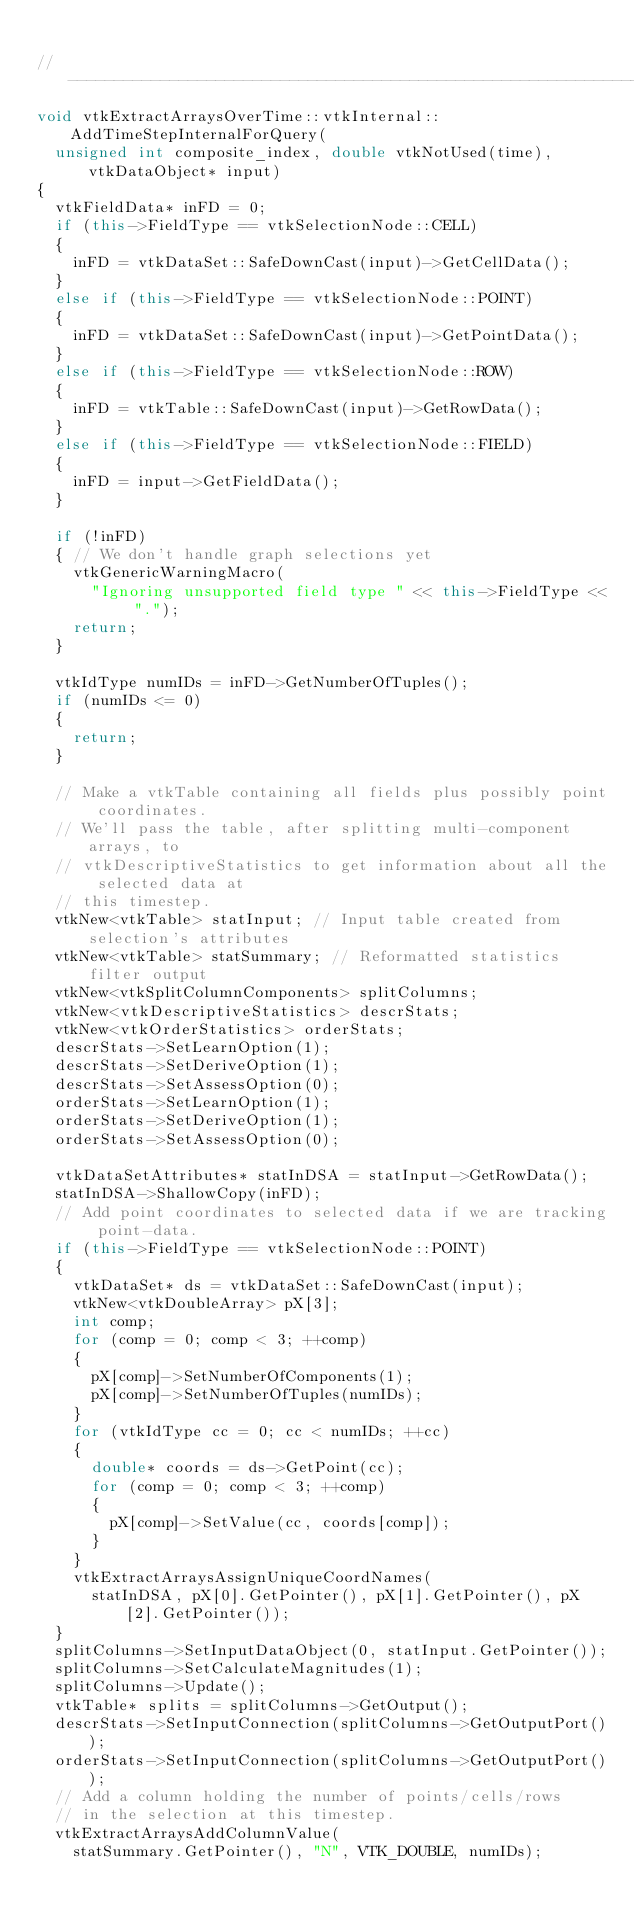<code> <loc_0><loc_0><loc_500><loc_500><_C++_>
//------------------------------------------------------------------------------
void vtkExtractArraysOverTime::vtkInternal::AddTimeStepInternalForQuery(
  unsigned int composite_index, double vtkNotUsed(time), vtkDataObject* input)
{
  vtkFieldData* inFD = 0;
  if (this->FieldType == vtkSelectionNode::CELL)
  {
    inFD = vtkDataSet::SafeDownCast(input)->GetCellData();
  }
  else if (this->FieldType == vtkSelectionNode::POINT)
  {
    inFD = vtkDataSet::SafeDownCast(input)->GetPointData();
  }
  else if (this->FieldType == vtkSelectionNode::ROW)
  {
    inFD = vtkTable::SafeDownCast(input)->GetRowData();
  }
  else if (this->FieldType == vtkSelectionNode::FIELD)
  {
    inFD = input->GetFieldData();
  }

  if (!inFD)
  { // We don't handle graph selections yet
    vtkGenericWarningMacro(
      "Ignoring unsupported field type " << this->FieldType << ".");
    return;
  }

  vtkIdType numIDs = inFD->GetNumberOfTuples();
  if (numIDs <= 0)
  {
    return;
  }

  // Make a vtkTable containing all fields plus possibly point coordinates.
  // We'll pass the table, after splitting multi-component arrays, to
  // vtkDescriptiveStatistics to get information about all the selected data at
  // this timestep.
  vtkNew<vtkTable> statInput; // Input table created from selection's attributes
  vtkNew<vtkTable> statSummary; // Reformatted statistics filter output
  vtkNew<vtkSplitColumnComponents> splitColumns;
  vtkNew<vtkDescriptiveStatistics> descrStats;
  vtkNew<vtkOrderStatistics> orderStats;
  descrStats->SetLearnOption(1);
  descrStats->SetDeriveOption(1);
  descrStats->SetAssessOption(0);
  orderStats->SetLearnOption(1);
  orderStats->SetDeriveOption(1);
  orderStats->SetAssessOption(0);

  vtkDataSetAttributes* statInDSA = statInput->GetRowData();
  statInDSA->ShallowCopy(inFD);
  // Add point coordinates to selected data if we are tracking point-data.
  if (this->FieldType == vtkSelectionNode::POINT)
  {
    vtkDataSet* ds = vtkDataSet::SafeDownCast(input);
    vtkNew<vtkDoubleArray> pX[3];
    int comp;
    for (comp = 0; comp < 3; ++comp)
    {
      pX[comp]->SetNumberOfComponents(1);
      pX[comp]->SetNumberOfTuples(numIDs);
    }
    for (vtkIdType cc = 0; cc < numIDs; ++cc)
    {
      double* coords = ds->GetPoint(cc);
      for (comp = 0; comp < 3; ++comp)
      {
        pX[comp]->SetValue(cc, coords[comp]);
      }
    }
    vtkExtractArraysAssignUniqueCoordNames(
      statInDSA, pX[0].GetPointer(), pX[1].GetPointer(), pX[2].GetPointer());
  }
  splitColumns->SetInputDataObject(0, statInput.GetPointer());
  splitColumns->SetCalculateMagnitudes(1);
  splitColumns->Update();
  vtkTable* splits = splitColumns->GetOutput();
  descrStats->SetInputConnection(splitColumns->GetOutputPort());
  orderStats->SetInputConnection(splitColumns->GetOutputPort());
  // Add a column holding the number of points/cells/rows
  // in the selection at this timestep.
  vtkExtractArraysAddColumnValue(
    statSummary.GetPointer(), "N", VTK_DOUBLE, numIDs);</code> 